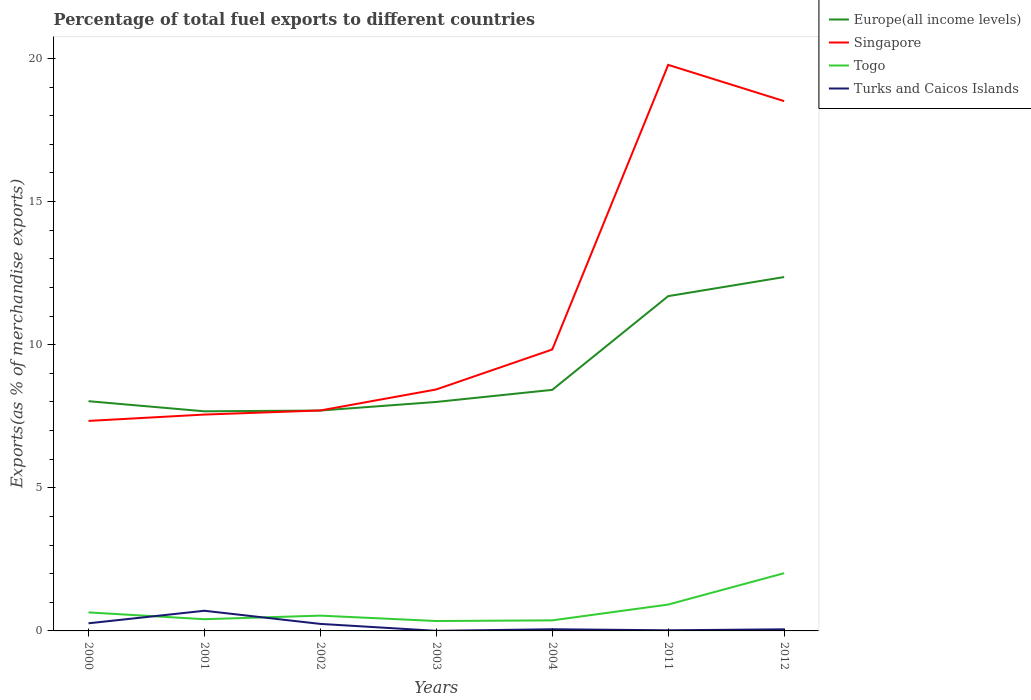Across all years, what is the maximum percentage of exports to different countries in Turks and Caicos Islands?
Offer a terse response. 0. What is the total percentage of exports to different countries in Singapore in the graph?
Offer a terse response. -2.13. What is the difference between the highest and the second highest percentage of exports to different countries in Togo?
Give a very brief answer. 1.67. What is the difference between the highest and the lowest percentage of exports to different countries in Europe(all income levels)?
Offer a terse response. 2. Is the percentage of exports to different countries in Turks and Caicos Islands strictly greater than the percentage of exports to different countries in Togo over the years?
Give a very brief answer. No. Are the values on the major ticks of Y-axis written in scientific E-notation?
Give a very brief answer. No. Does the graph contain any zero values?
Provide a short and direct response. No. Does the graph contain grids?
Ensure brevity in your answer.  No. How many legend labels are there?
Make the answer very short. 4. How are the legend labels stacked?
Offer a terse response. Vertical. What is the title of the graph?
Your response must be concise. Percentage of total fuel exports to different countries. Does "Tunisia" appear as one of the legend labels in the graph?
Your answer should be compact. No. What is the label or title of the Y-axis?
Offer a very short reply. Exports(as % of merchandise exports). What is the Exports(as % of merchandise exports) of Europe(all income levels) in 2000?
Offer a very short reply. 8.03. What is the Exports(as % of merchandise exports) in Singapore in 2000?
Give a very brief answer. 7.34. What is the Exports(as % of merchandise exports) in Togo in 2000?
Provide a short and direct response. 0.65. What is the Exports(as % of merchandise exports) in Turks and Caicos Islands in 2000?
Provide a short and direct response. 0.27. What is the Exports(as % of merchandise exports) in Europe(all income levels) in 2001?
Offer a terse response. 7.67. What is the Exports(as % of merchandise exports) in Singapore in 2001?
Make the answer very short. 7.56. What is the Exports(as % of merchandise exports) of Togo in 2001?
Your answer should be very brief. 0.41. What is the Exports(as % of merchandise exports) in Turks and Caicos Islands in 2001?
Your answer should be very brief. 0.7. What is the Exports(as % of merchandise exports) of Europe(all income levels) in 2002?
Make the answer very short. 7.7. What is the Exports(as % of merchandise exports) of Singapore in 2002?
Offer a very short reply. 7.7. What is the Exports(as % of merchandise exports) of Togo in 2002?
Your answer should be very brief. 0.53. What is the Exports(as % of merchandise exports) of Turks and Caicos Islands in 2002?
Make the answer very short. 0.24. What is the Exports(as % of merchandise exports) in Europe(all income levels) in 2003?
Your answer should be very brief. 8. What is the Exports(as % of merchandise exports) of Singapore in 2003?
Your response must be concise. 8.44. What is the Exports(as % of merchandise exports) of Togo in 2003?
Your answer should be compact. 0.35. What is the Exports(as % of merchandise exports) in Turks and Caicos Islands in 2003?
Give a very brief answer. 0. What is the Exports(as % of merchandise exports) of Europe(all income levels) in 2004?
Keep it short and to the point. 8.42. What is the Exports(as % of merchandise exports) in Singapore in 2004?
Make the answer very short. 9.83. What is the Exports(as % of merchandise exports) in Togo in 2004?
Your response must be concise. 0.37. What is the Exports(as % of merchandise exports) in Turks and Caicos Islands in 2004?
Your response must be concise. 0.06. What is the Exports(as % of merchandise exports) in Europe(all income levels) in 2011?
Offer a very short reply. 11.7. What is the Exports(as % of merchandise exports) in Singapore in 2011?
Ensure brevity in your answer.  19.78. What is the Exports(as % of merchandise exports) of Togo in 2011?
Keep it short and to the point. 0.92. What is the Exports(as % of merchandise exports) of Turks and Caicos Islands in 2011?
Offer a very short reply. 0.02. What is the Exports(as % of merchandise exports) of Europe(all income levels) in 2012?
Ensure brevity in your answer.  12.36. What is the Exports(as % of merchandise exports) in Singapore in 2012?
Ensure brevity in your answer.  18.51. What is the Exports(as % of merchandise exports) of Togo in 2012?
Give a very brief answer. 2.02. What is the Exports(as % of merchandise exports) of Turks and Caicos Islands in 2012?
Your answer should be very brief. 0.06. Across all years, what is the maximum Exports(as % of merchandise exports) of Europe(all income levels)?
Your answer should be very brief. 12.36. Across all years, what is the maximum Exports(as % of merchandise exports) of Singapore?
Ensure brevity in your answer.  19.78. Across all years, what is the maximum Exports(as % of merchandise exports) of Togo?
Offer a terse response. 2.02. Across all years, what is the maximum Exports(as % of merchandise exports) in Turks and Caicos Islands?
Provide a short and direct response. 0.7. Across all years, what is the minimum Exports(as % of merchandise exports) of Europe(all income levels)?
Offer a very short reply. 7.67. Across all years, what is the minimum Exports(as % of merchandise exports) in Singapore?
Offer a very short reply. 7.34. Across all years, what is the minimum Exports(as % of merchandise exports) of Togo?
Offer a very short reply. 0.35. Across all years, what is the minimum Exports(as % of merchandise exports) of Turks and Caicos Islands?
Make the answer very short. 0. What is the total Exports(as % of merchandise exports) in Europe(all income levels) in the graph?
Provide a short and direct response. 63.88. What is the total Exports(as % of merchandise exports) in Singapore in the graph?
Provide a short and direct response. 79.15. What is the total Exports(as % of merchandise exports) of Togo in the graph?
Provide a succinct answer. 5.24. What is the total Exports(as % of merchandise exports) in Turks and Caicos Islands in the graph?
Keep it short and to the point. 1.36. What is the difference between the Exports(as % of merchandise exports) of Europe(all income levels) in 2000 and that in 2001?
Your answer should be compact. 0.35. What is the difference between the Exports(as % of merchandise exports) of Singapore in 2000 and that in 2001?
Offer a very short reply. -0.22. What is the difference between the Exports(as % of merchandise exports) in Togo in 2000 and that in 2001?
Provide a short and direct response. 0.24. What is the difference between the Exports(as % of merchandise exports) in Turks and Caicos Islands in 2000 and that in 2001?
Offer a terse response. -0.44. What is the difference between the Exports(as % of merchandise exports) in Europe(all income levels) in 2000 and that in 2002?
Keep it short and to the point. 0.33. What is the difference between the Exports(as % of merchandise exports) in Singapore in 2000 and that in 2002?
Keep it short and to the point. -0.37. What is the difference between the Exports(as % of merchandise exports) in Togo in 2000 and that in 2002?
Your answer should be very brief. 0.11. What is the difference between the Exports(as % of merchandise exports) in Turks and Caicos Islands in 2000 and that in 2002?
Your answer should be very brief. 0.02. What is the difference between the Exports(as % of merchandise exports) of Europe(all income levels) in 2000 and that in 2003?
Make the answer very short. 0.03. What is the difference between the Exports(as % of merchandise exports) of Togo in 2000 and that in 2003?
Offer a terse response. 0.3. What is the difference between the Exports(as % of merchandise exports) in Turks and Caicos Islands in 2000 and that in 2003?
Offer a terse response. 0.26. What is the difference between the Exports(as % of merchandise exports) of Europe(all income levels) in 2000 and that in 2004?
Offer a very short reply. -0.4. What is the difference between the Exports(as % of merchandise exports) of Singapore in 2000 and that in 2004?
Make the answer very short. -2.5. What is the difference between the Exports(as % of merchandise exports) of Togo in 2000 and that in 2004?
Provide a succinct answer. 0.28. What is the difference between the Exports(as % of merchandise exports) of Turks and Caicos Islands in 2000 and that in 2004?
Provide a succinct answer. 0.21. What is the difference between the Exports(as % of merchandise exports) in Europe(all income levels) in 2000 and that in 2011?
Provide a succinct answer. -3.67. What is the difference between the Exports(as % of merchandise exports) in Singapore in 2000 and that in 2011?
Provide a succinct answer. -12.44. What is the difference between the Exports(as % of merchandise exports) in Togo in 2000 and that in 2011?
Make the answer very short. -0.27. What is the difference between the Exports(as % of merchandise exports) of Turks and Caicos Islands in 2000 and that in 2011?
Your answer should be compact. 0.24. What is the difference between the Exports(as % of merchandise exports) in Europe(all income levels) in 2000 and that in 2012?
Your answer should be compact. -4.34. What is the difference between the Exports(as % of merchandise exports) of Singapore in 2000 and that in 2012?
Make the answer very short. -11.17. What is the difference between the Exports(as % of merchandise exports) in Togo in 2000 and that in 2012?
Keep it short and to the point. -1.37. What is the difference between the Exports(as % of merchandise exports) in Turks and Caicos Islands in 2000 and that in 2012?
Offer a very short reply. 0.21. What is the difference between the Exports(as % of merchandise exports) in Europe(all income levels) in 2001 and that in 2002?
Your answer should be very brief. -0.03. What is the difference between the Exports(as % of merchandise exports) of Singapore in 2001 and that in 2002?
Give a very brief answer. -0.14. What is the difference between the Exports(as % of merchandise exports) in Togo in 2001 and that in 2002?
Offer a terse response. -0.13. What is the difference between the Exports(as % of merchandise exports) in Turks and Caicos Islands in 2001 and that in 2002?
Offer a very short reply. 0.46. What is the difference between the Exports(as % of merchandise exports) of Europe(all income levels) in 2001 and that in 2003?
Your answer should be very brief. -0.33. What is the difference between the Exports(as % of merchandise exports) in Singapore in 2001 and that in 2003?
Keep it short and to the point. -0.88. What is the difference between the Exports(as % of merchandise exports) of Togo in 2001 and that in 2003?
Ensure brevity in your answer.  0.06. What is the difference between the Exports(as % of merchandise exports) in Turks and Caicos Islands in 2001 and that in 2003?
Offer a terse response. 0.7. What is the difference between the Exports(as % of merchandise exports) in Europe(all income levels) in 2001 and that in 2004?
Offer a very short reply. -0.75. What is the difference between the Exports(as % of merchandise exports) of Singapore in 2001 and that in 2004?
Your answer should be compact. -2.27. What is the difference between the Exports(as % of merchandise exports) of Togo in 2001 and that in 2004?
Keep it short and to the point. 0.04. What is the difference between the Exports(as % of merchandise exports) in Turks and Caicos Islands in 2001 and that in 2004?
Your answer should be compact. 0.65. What is the difference between the Exports(as % of merchandise exports) in Europe(all income levels) in 2001 and that in 2011?
Ensure brevity in your answer.  -4.02. What is the difference between the Exports(as % of merchandise exports) of Singapore in 2001 and that in 2011?
Provide a short and direct response. -12.22. What is the difference between the Exports(as % of merchandise exports) of Togo in 2001 and that in 2011?
Your response must be concise. -0.51. What is the difference between the Exports(as % of merchandise exports) of Turks and Caicos Islands in 2001 and that in 2011?
Give a very brief answer. 0.68. What is the difference between the Exports(as % of merchandise exports) in Europe(all income levels) in 2001 and that in 2012?
Your answer should be very brief. -4.69. What is the difference between the Exports(as % of merchandise exports) of Singapore in 2001 and that in 2012?
Ensure brevity in your answer.  -10.95. What is the difference between the Exports(as % of merchandise exports) of Togo in 2001 and that in 2012?
Offer a terse response. -1.61. What is the difference between the Exports(as % of merchandise exports) in Turks and Caicos Islands in 2001 and that in 2012?
Offer a terse response. 0.65. What is the difference between the Exports(as % of merchandise exports) in Europe(all income levels) in 2002 and that in 2003?
Offer a very short reply. -0.3. What is the difference between the Exports(as % of merchandise exports) of Singapore in 2002 and that in 2003?
Your answer should be compact. -0.73. What is the difference between the Exports(as % of merchandise exports) of Togo in 2002 and that in 2003?
Provide a short and direct response. 0.19. What is the difference between the Exports(as % of merchandise exports) in Turks and Caicos Islands in 2002 and that in 2003?
Keep it short and to the point. 0.24. What is the difference between the Exports(as % of merchandise exports) of Europe(all income levels) in 2002 and that in 2004?
Make the answer very short. -0.72. What is the difference between the Exports(as % of merchandise exports) in Singapore in 2002 and that in 2004?
Keep it short and to the point. -2.13. What is the difference between the Exports(as % of merchandise exports) in Togo in 2002 and that in 2004?
Offer a very short reply. 0.17. What is the difference between the Exports(as % of merchandise exports) in Turks and Caicos Islands in 2002 and that in 2004?
Provide a short and direct response. 0.19. What is the difference between the Exports(as % of merchandise exports) in Europe(all income levels) in 2002 and that in 2011?
Provide a short and direct response. -4. What is the difference between the Exports(as % of merchandise exports) in Singapore in 2002 and that in 2011?
Offer a very short reply. -12.07. What is the difference between the Exports(as % of merchandise exports) in Togo in 2002 and that in 2011?
Provide a succinct answer. -0.39. What is the difference between the Exports(as % of merchandise exports) of Turks and Caicos Islands in 2002 and that in 2011?
Your answer should be very brief. 0.22. What is the difference between the Exports(as % of merchandise exports) of Europe(all income levels) in 2002 and that in 2012?
Give a very brief answer. -4.66. What is the difference between the Exports(as % of merchandise exports) of Singapore in 2002 and that in 2012?
Provide a short and direct response. -10.81. What is the difference between the Exports(as % of merchandise exports) in Togo in 2002 and that in 2012?
Your response must be concise. -1.48. What is the difference between the Exports(as % of merchandise exports) of Turks and Caicos Islands in 2002 and that in 2012?
Your response must be concise. 0.19. What is the difference between the Exports(as % of merchandise exports) in Europe(all income levels) in 2003 and that in 2004?
Give a very brief answer. -0.42. What is the difference between the Exports(as % of merchandise exports) of Singapore in 2003 and that in 2004?
Make the answer very short. -1.4. What is the difference between the Exports(as % of merchandise exports) of Togo in 2003 and that in 2004?
Provide a short and direct response. -0.02. What is the difference between the Exports(as % of merchandise exports) of Turks and Caicos Islands in 2003 and that in 2004?
Ensure brevity in your answer.  -0.06. What is the difference between the Exports(as % of merchandise exports) of Europe(all income levels) in 2003 and that in 2011?
Provide a succinct answer. -3.7. What is the difference between the Exports(as % of merchandise exports) in Singapore in 2003 and that in 2011?
Your answer should be compact. -11.34. What is the difference between the Exports(as % of merchandise exports) in Togo in 2003 and that in 2011?
Make the answer very short. -0.58. What is the difference between the Exports(as % of merchandise exports) of Turks and Caicos Islands in 2003 and that in 2011?
Offer a very short reply. -0.02. What is the difference between the Exports(as % of merchandise exports) in Europe(all income levels) in 2003 and that in 2012?
Provide a succinct answer. -4.36. What is the difference between the Exports(as % of merchandise exports) in Singapore in 2003 and that in 2012?
Ensure brevity in your answer.  -10.07. What is the difference between the Exports(as % of merchandise exports) in Togo in 2003 and that in 2012?
Provide a succinct answer. -1.67. What is the difference between the Exports(as % of merchandise exports) in Turks and Caicos Islands in 2003 and that in 2012?
Offer a terse response. -0.05. What is the difference between the Exports(as % of merchandise exports) of Europe(all income levels) in 2004 and that in 2011?
Offer a terse response. -3.27. What is the difference between the Exports(as % of merchandise exports) in Singapore in 2004 and that in 2011?
Keep it short and to the point. -9.94. What is the difference between the Exports(as % of merchandise exports) of Togo in 2004 and that in 2011?
Your response must be concise. -0.55. What is the difference between the Exports(as % of merchandise exports) of Turks and Caicos Islands in 2004 and that in 2011?
Give a very brief answer. 0.04. What is the difference between the Exports(as % of merchandise exports) in Europe(all income levels) in 2004 and that in 2012?
Your response must be concise. -3.94. What is the difference between the Exports(as % of merchandise exports) of Singapore in 2004 and that in 2012?
Ensure brevity in your answer.  -8.68. What is the difference between the Exports(as % of merchandise exports) in Togo in 2004 and that in 2012?
Keep it short and to the point. -1.65. What is the difference between the Exports(as % of merchandise exports) in Turks and Caicos Islands in 2004 and that in 2012?
Provide a short and direct response. 0. What is the difference between the Exports(as % of merchandise exports) of Europe(all income levels) in 2011 and that in 2012?
Your answer should be very brief. -0.67. What is the difference between the Exports(as % of merchandise exports) in Singapore in 2011 and that in 2012?
Make the answer very short. 1.27. What is the difference between the Exports(as % of merchandise exports) in Togo in 2011 and that in 2012?
Your answer should be compact. -1.1. What is the difference between the Exports(as % of merchandise exports) in Turks and Caicos Islands in 2011 and that in 2012?
Your answer should be compact. -0.04. What is the difference between the Exports(as % of merchandise exports) in Europe(all income levels) in 2000 and the Exports(as % of merchandise exports) in Singapore in 2001?
Provide a short and direct response. 0.47. What is the difference between the Exports(as % of merchandise exports) of Europe(all income levels) in 2000 and the Exports(as % of merchandise exports) of Togo in 2001?
Make the answer very short. 7.62. What is the difference between the Exports(as % of merchandise exports) of Europe(all income levels) in 2000 and the Exports(as % of merchandise exports) of Turks and Caicos Islands in 2001?
Offer a terse response. 7.32. What is the difference between the Exports(as % of merchandise exports) of Singapore in 2000 and the Exports(as % of merchandise exports) of Togo in 2001?
Your answer should be very brief. 6.93. What is the difference between the Exports(as % of merchandise exports) in Singapore in 2000 and the Exports(as % of merchandise exports) in Turks and Caicos Islands in 2001?
Ensure brevity in your answer.  6.63. What is the difference between the Exports(as % of merchandise exports) of Togo in 2000 and the Exports(as % of merchandise exports) of Turks and Caicos Islands in 2001?
Your answer should be very brief. -0.06. What is the difference between the Exports(as % of merchandise exports) in Europe(all income levels) in 2000 and the Exports(as % of merchandise exports) in Singapore in 2002?
Your response must be concise. 0.32. What is the difference between the Exports(as % of merchandise exports) in Europe(all income levels) in 2000 and the Exports(as % of merchandise exports) in Togo in 2002?
Make the answer very short. 7.49. What is the difference between the Exports(as % of merchandise exports) of Europe(all income levels) in 2000 and the Exports(as % of merchandise exports) of Turks and Caicos Islands in 2002?
Offer a very short reply. 7.78. What is the difference between the Exports(as % of merchandise exports) of Singapore in 2000 and the Exports(as % of merchandise exports) of Togo in 2002?
Offer a very short reply. 6.8. What is the difference between the Exports(as % of merchandise exports) in Singapore in 2000 and the Exports(as % of merchandise exports) in Turks and Caicos Islands in 2002?
Provide a short and direct response. 7.09. What is the difference between the Exports(as % of merchandise exports) of Togo in 2000 and the Exports(as % of merchandise exports) of Turks and Caicos Islands in 2002?
Keep it short and to the point. 0.4. What is the difference between the Exports(as % of merchandise exports) in Europe(all income levels) in 2000 and the Exports(as % of merchandise exports) in Singapore in 2003?
Make the answer very short. -0.41. What is the difference between the Exports(as % of merchandise exports) of Europe(all income levels) in 2000 and the Exports(as % of merchandise exports) of Togo in 2003?
Your answer should be very brief. 7.68. What is the difference between the Exports(as % of merchandise exports) of Europe(all income levels) in 2000 and the Exports(as % of merchandise exports) of Turks and Caicos Islands in 2003?
Keep it short and to the point. 8.02. What is the difference between the Exports(as % of merchandise exports) in Singapore in 2000 and the Exports(as % of merchandise exports) in Togo in 2003?
Offer a very short reply. 6.99. What is the difference between the Exports(as % of merchandise exports) of Singapore in 2000 and the Exports(as % of merchandise exports) of Turks and Caicos Islands in 2003?
Give a very brief answer. 7.33. What is the difference between the Exports(as % of merchandise exports) of Togo in 2000 and the Exports(as % of merchandise exports) of Turks and Caicos Islands in 2003?
Offer a very short reply. 0.64. What is the difference between the Exports(as % of merchandise exports) in Europe(all income levels) in 2000 and the Exports(as % of merchandise exports) in Singapore in 2004?
Offer a terse response. -1.81. What is the difference between the Exports(as % of merchandise exports) in Europe(all income levels) in 2000 and the Exports(as % of merchandise exports) in Togo in 2004?
Your answer should be compact. 7.66. What is the difference between the Exports(as % of merchandise exports) of Europe(all income levels) in 2000 and the Exports(as % of merchandise exports) of Turks and Caicos Islands in 2004?
Offer a very short reply. 7.97. What is the difference between the Exports(as % of merchandise exports) of Singapore in 2000 and the Exports(as % of merchandise exports) of Togo in 2004?
Offer a very short reply. 6.97. What is the difference between the Exports(as % of merchandise exports) of Singapore in 2000 and the Exports(as % of merchandise exports) of Turks and Caicos Islands in 2004?
Keep it short and to the point. 7.28. What is the difference between the Exports(as % of merchandise exports) in Togo in 2000 and the Exports(as % of merchandise exports) in Turks and Caicos Islands in 2004?
Offer a very short reply. 0.59. What is the difference between the Exports(as % of merchandise exports) in Europe(all income levels) in 2000 and the Exports(as % of merchandise exports) in Singapore in 2011?
Your answer should be compact. -11.75. What is the difference between the Exports(as % of merchandise exports) in Europe(all income levels) in 2000 and the Exports(as % of merchandise exports) in Togo in 2011?
Provide a short and direct response. 7.1. What is the difference between the Exports(as % of merchandise exports) of Europe(all income levels) in 2000 and the Exports(as % of merchandise exports) of Turks and Caicos Islands in 2011?
Give a very brief answer. 8. What is the difference between the Exports(as % of merchandise exports) of Singapore in 2000 and the Exports(as % of merchandise exports) of Togo in 2011?
Offer a very short reply. 6.42. What is the difference between the Exports(as % of merchandise exports) of Singapore in 2000 and the Exports(as % of merchandise exports) of Turks and Caicos Islands in 2011?
Keep it short and to the point. 7.32. What is the difference between the Exports(as % of merchandise exports) in Togo in 2000 and the Exports(as % of merchandise exports) in Turks and Caicos Islands in 2011?
Provide a succinct answer. 0.62. What is the difference between the Exports(as % of merchandise exports) of Europe(all income levels) in 2000 and the Exports(as % of merchandise exports) of Singapore in 2012?
Give a very brief answer. -10.48. What is the difference between the Exports(as % of merchandise exports) in Europe(all income levels) in 2000 and the Exports(as % of merchandise exports) in Togo in 2012?
Keep it short and to the point. 6.01. What is the difference between the Exports(as % of merchandise exports) in Europe(all income levels) in 2000 and the Exports(as % of merchandise exports) in Turks and Caicos Islands in 2012?
Make the answer very short. 7.97. What is the difference between the Exports(as % of merchandise exports) of Singapore in 2000 and the Exports(as % of merchandise exports) of Togo in 2012?
Keep it short and to the point. 5.32. What is the difference between the Exports(as % of merchandise exports) of Singapore in 2000 and the Exports(as % of merchandise exports) of Turks and Caicos Islands in 2012?
Your answer should be very brief. 7.28. What is the difference between the Exports(as % of merchandise exports) in Togo in 2000 and the Exports(as % of merchandise exports) in Turks and Caicos Islands in 2012?
Your answer should be very brief. 0.59. What is the difference between the Exports(as % of merchandise exports) of Europe(all income levels) in 2001 and the Exports(as % of merchandise exports) of Singapore in 2002?
Ensure brevity in your answer.  -0.03. What is the difference between the Exports(as % of merchandise exports) of Europe(all income levels) in 2001 and the Exports(as % of merchandise exports) of Togo in 2002?
Provide a succinct answer. 7.14. What is the difference between the Exports(as % of merchandise exports) of Europe(all income levels) in 2001 and the Exports(as % of merchandise exports) of Turks and Caicos Islands in 2002?
Provide a succinct answer. 7.43. What is the difference between the Exports(as % of merchandise exports) of Singapore in 2001 and the Exports(as % of merchandise exports) of Togo in 2002?
Your answer should be compact. 7.03. What is the difference between the Exports(as % of merchandise exports) in Singapore in 2001 and the Exports(as % of merchandise exports) in Turks and Caicos Islands in 2002?
Offer a terse response. 7.31. What is the difference between the Exports(as % of merchandise exports) in Togo in 2001 and the Exports(as % of merchandise exports) in Turks and Caicos Islands in 2002?
Offer a terse response. 0.16. What is the difference between the Exports(as % of merchandise exports) in Europe(all income levels) in 2001 and the Exports(as % of merchandise exports) in Singapore in 2003?
Your answer should be compact. -0.76. What is the difference between the Exports(as % of merchandise exports) of Europe(all income levels) in 2001 and the Exports(as % of merchandise exports) of Togo in 2003?
Your response must be concise. 7.33. What is the difference between the Exports(as % of merchandise exports) in Europe(all income levels) in 2001 and the Exports(as % of merchandise exports) in Turks and Caicos Islands in 2003?
Give a very brief answer. 7.67. What is the difference between the Exports(as % of merchandise exports) in Singapore in 2001 and the Exports(as % of merchandise exports) in Togo in 2003?
Your response must be concise. 7.21. What is the difference between the Exports(as % of merchandise exports) of Singapore in 2001 and the Exports(as % of merchandise exports) of Turks and Caicos Islands in 2003?
Make the answer very short. 7.56. What is the difference between the Exports(as % of merchandise exports) of Togo in 2001 and the Exports(as % of merchandise exports) of Turks and Caicos Islands in 2003?
Make the answer very short. 0.41. What is the difference between the Exports(as % of merchandise exports) in Europe(all income levels) in 2001 and the Exports(as % of merchandise exports) in Singapore in 2004?
Your answer should be compact. -2.16. What is the difference between the Exports(as % of merchandise exports) of Europe(all income levels) in 2001 and the Exports(as % of merchandise exports) of Togo in 2004?
Ensure brevity in your answer.  7.3. What is the difference between the Exports(as % of merchandise exports) of Europe(all income levels) in 2001 and the Exports(as % of merchandise exports) of Turks and Caicos Islands in 2004?
Your answer should be compact. 7.61. What is the difference between the Exports(as % of merchandise exports) of Singapore in 2001 and the Exports(as % of merchandise exports) of Togo in 2004?
Offer a very short reply. 7.19. What is the difference between the Exports(as % of merchandise exports) in Singapore in 2001 and the Exports(as % of merchandise exports) in Turks and Caicos Islands in 2004?
Ensure brevity in your answer.  7.5. What is the difference between the Exports(as % of merchandise exports) of Togo in 2001 and the Exports(as % of merchandise exports) of Turks and Caicos Islands in 2004?
Ensure brevity in your answer.  0.35. What is the difference between the Exports(as % of merchandise exports) in Europe(all income levels) in 2001 and the Exports(as % of merchandise exports) in Singapore in 2011?
Provide a succinct answer. -12.1. What is the difference between the Exports(as % of merchandise exports) of Europe(all income levels) in 2001 and the Exports(as % of merchandise exports) of Togo in 2011?
Keep it short and to the point. 6.75. What is the difference between the Exports(as % of merchandise exports) of Europe(all income levels) in 2001 and the Exports(as % of merchandise exports) of Turks and Caicos Islands in 2011?
Keep it short and to the point. 7.65. What is the difference between the Exports(as % of merchandise exports) in Singapore in 2001 and the Exports(as % of merchandise exports) in Togo in 2011?
Give a very brief answer. 6.64. What is the difference between the Exports(as % of merchandise exports) in Singapore in 2001 and the Exports(as % of merchandise exports) in Turks and Caicos Islands in 2011?
Offer a very short reply. 7.54. What is the difference between the Exports(as % of merchandise exports) of Togo in 2001 and the Exports(as % of merchandise exports) of Turks and Caicos Islands in 2011?
Make the answer very short. 0.39. What is the difference between the Exports(as % of merchandise exports) in Europe(all income levels) in 2001 and the Exports(as % of merchandise exports) in Singapore in 2012?
Give a very brief answer. -10.84. What is the difference between the Exports(as % of merchandise exports) in Europe(all income levels) in 2001 and the Exports(as % of merchandise exports) in Togo in 2012?
Your response must be concise. 5.66. What is the difference between the Exports(as % of merchandise exports) in Europe(all income levels) in 2001 and the Exports(as % of merchandise exports) in Turks and Caicos Islands in 2012?
Provide a short and direct response. 7.62. What is the difference between the Exports(as % of merchandise exports) of Singapore in 2001 and the Exports(as % of merchandise exports) of Togo in 2012?
Give a very brief answer. 5.54. What is the difference between the Exports(as % of merchandise exports) in Singapore in 2001 and the Exports(as % of merchandise exports) in Turks and Caicos Islands in 2012?
Make the answer very short. 7.5. What is the difference between the Exports(as % of merchandise exports) in Togo in 2001 and the Exports(as % of merchandise exports) in Turks and Caicos Islands in 2012?
Your answer should be compact. 0.35. What is the difference between the Exports(as % of merchandise exports) of Europe(all income levels) in 2002 and the Exports(as % of merchandise exports) of Singapore in 2003?
Your answer should be very brief. -0.74. What is the difference between the Exports(as % of merchandise exports) of Europe(all income levels) in 2002 and the Exports(as % of merchandise exports) of Togo in 2003?
Offer a very short reply. 7.35. What is the difference between the Exports(as % of merchandise exports) of Europe(all income levels) in 2002 and the Exports(as % of merchandise exports) of Turks and Caicos Islands in 2003?
Offer a terse response. 7.7. What is the difference between the Exports(as % of merchandise exports) of Singapore in 2002 and the Exports(as % of merchandise exports) of Togo in 2003?
Provide a short and direct response. 7.36. What is the difference between the Exports(as % of merchandise exports) in Singapore in 2002 and the Exports(as % of merchandise exports) in Turks and Caicos Islands in 2003?
Ensure brevity in your answer.  7.7. What is the difference between the Exports(as % of merchandise exports) of Togo in 2002 and the Exports(as % of merchandise exports) of Turks and Caicos Islands in 2003?
Offer a very short reply. 0.53. What is the difference between the Exports(as % of merchandise exports) in Europe(all income levels) in 2002 and the Exports(as % of merchandise exports) in Singapore in 2004?
Provide a short and direct response. -2.13. What is the difference between the Exports(as % of merchandise exports) in Europe(all income levels) in 2002 and the Exports(as % of merchandise exports) in Togo in 2004?
Give a very brief answer. 7.33. What is the difference between the Exports(as % of merchandise exports) in Europe(all income levels) in 2002 and the Exports(as % of merchandise exports) in Turks and Caicos Islands in 2004?
Your answer should be very brief. 7.64. What is the difference between the Exports(as % of merchandise exports) in Singapore in 2002 and the Exports(as % of merchandise exports) in Togo in 2004?
Give a very brief answer. 7.33. What is the difference between the Exports(as % of merchandise exports) of Singapore in 2002 and the Exports(as % of merchandise exports) of Turks and Caicos Islands in 2004?
Provide a succinct answer. 7.64. What is the difference between the Exports(as % of merchandise exports) in Togo in 2002 and the Exports(as % of merchandise exports) in Turks and Caicos Islands in 2004?
Provide a succinct answer. 0.48. What is the difference between the Exports(as % of merchandise exports) in Europe(all income levels) in 2002 and the Exports(as % of merchandise exports) in Singapore in 2011?
Offer a very short reply. -12.08. What is the difference between the Exports(as % of merchandise exports) of Europe(all income levels) in 2002 and the Exports(as % of merchandise exports) of Togo in 2011?
Give a very brief answer. 6.78. What is the difference between the Exports(as % of merchandise exports) in Europe(all income levels) in 2002 and the Exports(as % of merchandise exports) in Turks and Caicos Islands in 2011?
Offer a terse response. 7.68. What is the difference between the Exports(as % of merchandise exports) in Singapore in 2002 and the Exports(as % of merchandise exports) in Togo in 2011?
Make the answer very short. 6.78. What is the difference between the Exports(as % of merchandise exports) of Singapore in 2002 and the Exports(as % of merchandise exports) of Turks and Caicos Islands in 2011?
Your answer should be very brief. 7.68. What is the difference between the Exports(as % of merchandise exports) in Togo in 2002 and the Exports(as % of merchandise exports) in Turks and Caicos Islands in 2011?
Provide a succinct answer. 0.51. What is the difference between the Exports(as % of merchandise exports) of Europe(all income levels) in 2002 and the Exports(as % of merchandise exports) of Singapore in 2012?
Provide a succinct answer. -10.81. What is the difference between the Exports(as % of merchandise exports) in Europe(all income levels) in 2002 and the Exports(as % of merchandise exports) in Togo in 2012?
Keep it short and to the point. 5.68. What is the difference between the Exports(as % of merchandise exports) in Europe(all income levels) in 2002 and the Exports(as % of merchandise exports) in Turks and Caicos Islands in 2012?
Ensure brevity in your answer.  7.64. What is the difference between the Exports(as % of merchandise exports) in Singapore in 2002 and the Exports(as % of merchandise exports) in Togo in 2012?
Give a very brief answer. 5.68. What is the difference between the Exports(as % of merchandise exports) in Singapore in 2002 and the Exports(as % of merchandise exports) in Turks and Caicos Islands in 2012?
Keep it short and to the point. 7.65. What is the difference between the Exports(as % of merchandise exports) in Togo in 2002 and the Exports(as % of merchandise exports) in Turks and Caicos Islands in 2012?
Keep it short and to the point. 0.48. What is the difference between the Exports(as % of merchandise exports) of Europe(all income levels) in 2003 and the Exports(as % of merchandise exports) of Singapore in 2004?
Make the answer very short. -1.83. What is the difference between the Exports(as % of merchandise exports) of Europe(all income levels) in 2003 and the Exports(as % of merchandise exports) of Togo in 2004?
Make the answer very short. 7.63. What is the difference between the Exports(as % of merchandise exports) of Europe(all income levels) in 2003 and the Exports(as % of merchandise exports) of Turks and Caicos Islands in 2004?
Offer a very short reply. 7.94. What is the difference between the Exports(as % of merchandise exports) in Singapore in 2003 and the Exports(as % of merchandise exports) in Togo in 2004?
Your answer should be compact. 8.07. What is the difference between the Exports(as % of merchandise exports) of Singapore in 2003 and the Exports(as % of merchandise exports) of Turks and Caicos Islands in 2004?
Give a very brief answer. 8.38. What is the difference between the Exports(as % of merchandise exports) in Togo in 2003 and the Exports(as % of merchandise exports) in Turks and Caicos Islands in 2004?
Offer a very short reply. 0.29. What is the difference between the Exports(as % of merchandise exports) of Europe(all income levels) in 2003 and the Exports(as % of merchandise exports) of Singapore in 2011?
Keep it short and to the point. -11.78. What is the difference between the Exports(as % of merchandise exports) of Europe(all income levels) in 2003 and the Exports(as % of merchandise exports) of Togo in 2011?
Keep it short and to the point. 7.08. What is the difference between the Exports(as % of merchandise exports) in Europe(all income levels) in 2003 and the Exports(as % of merchandise exports) in Turks and Caicos Islands in 2011?
Give a very brief answer. 7.98. What is the difference between the Exports(as % of merchandise exports) of Singapore in 2003 and the Exports(as % of merchandise exports) of Togo in 2011?
Make the answer very short. 7.52. What is the difference between the Exports(as % of merchandise exports) in Singapore in 2003 and the Exports(as % of merchandise exports) in Turks and Caicos Islands in 2011?
Provide a succinct answer. 8.42. What is the difference between the Exports(as % of merchandise exports) in Togo in 2003 and the Exports(as % of merchandise exports) in Turks and Caicos Islands in 2011?
Give a very brief answer. 0.32. What is the difference between the Exports(as % of merchandise exports) of Europe(all income levels) in 2003 and the Exports(as % of merchandise exports) of Singapore in 2012?
Your answer should be compact. -10.51. What is the difference between the Exports(as % of merchandise exports) of Europe(all income levels) in 2003 and the Exports(as % of merchandise exports) of Togo in 2012?
Your answer should be compact. 5.98. What is the difference between the Exports(as % of merchandise exports) of Europe(all income levels) in 2003 and the Exports(as % of merchandise exports) of Turks and Caicos Islands in 2012?
Your response must be concise. 7.94. What is the difference between the Exports(as % of merchandise exports) of Singapore in 2003 and the Exports(as % of merchandise exports) of Togo in 2012?
Offer a very short reply. 6.42. What is the difference between the Exports(as % of merchandise exports) in Singapore in 2003 and the Exports(as % of merchandise exports) in Turks and Caicos Islands in 2012?
Your response must be concise. 8.38. What is the difference between the Exports(as % of merchandise exports) in Togo in 2003 and the Exports(as % of merchandise exports) in Turks and Caicos Islands in 2012?
Provide a succinct answer. 0.29. What is the difference between the Exports(as % of merchandise exports) in Europe(all income levels) in 2004 and the Exports(as % of merchandise exports) in Singapore in 2011?
Offer a very short reply. -11.35. What is the difference between the Exports(as % of merchandise exports) of Europe(all income levels) in 2004 and the Exports(as % of merchandise exports) of Togo in 2011?
Your response must be concise. 7.5. What is the difference between the Exports(as % of merchandise exports) of Europe(all income levels) in 2004 and the Exports(as % of merchandise exports) of Turks and Caicos Islands in 2011?
Offer a very short reply. 8.4. What is the difference between the Exports(as % of merchandise exports) in Singapore in 2004 and the Exports(as % of merchandise exports) in Togo in 2011?
Provide a succinct answer. 8.91. What is the difference between the Exports(as % of merchandise exports) in Singapore in 2004 and the Exports(as % of merchandise exports) in Turks and Caicos Islands in 2011?
Keep it short and to the point. 9.81. What is the difference between the Exports(as % of merchandise exports) in Togo in 2004 and the Exports(as % of merchandise exports) in Turks and Caicos Islands in 2011?
Your answer should be compact. 0.35. What is the difference between the Exports(as % of merchandise exports) of Europe(all income levels) in 2004 and the Exports(as % of merchandise exports) of Singapore in 2012?
Provide a succinct answer. -10.09. What is the difference between the Exports(as % of merchandise exports) of Europe(all income levels) in 2004 and the Exports(as % of merchandise exports) of Togo in 2012?
Keep it short and to the point. 6.4. What is the difference between the Exports(as % of merchandise exports) in Europe(all income levels) in 2004 and the Exports(as % of merchandise exports) in Turks and Caicos Islands in 2012?
Offer a very short reply. 8.37. What is the difference between the Exports(as % of merchandise exports) of Singapore in 2004 and the Exports(as % of merchandise exports) of Togo in 2012?
Offer a terse response. 7.81. What is the difference between the Exports(as % of merchandise exports) of Singapore in 2004 and the Exports(as % of merchandise exports) of Turks and Caicos Islands in 2012?
Keep it short and to the point. 9.78. What is the difference between the Exports(as % of merchandise exports) of Togo in 2004 and the Exports(as % of merchandise exports) of Turks and Caicos Islands in 2012?
Ensure brevity in your answer.  0.31. What is the difference between the Exports(as % of merchandise exports) of Europe(all income levels) in 2011 and the Exports(as % of merchandise exports) of Singapore in 2012?
Offer a terse response. -6.81. What is the difference between the Exports(as % of merchandise exports) of Europe(all income levels) in 2011 and the Exports(as % of merchandise exports) of Togo in 2012?
Your response must be concise. 9.68. What is the difference between the Exports(as % of merchandise exports) in Europe(all income levels) in 2011 and the Exports(as % of merchandise exports) in Turks and Caicos Islands in 2012?
Offer a very short reply. 11.64. What is the difference between the Exports(as % of merchandise exports) in Singapore in 2011 and the Exports(as % of merchandise exports) in Togo in 2012?
Make the answer very short. 17.76. What is the difference between the Exports(as % of merchandise exports) of Singapore in 2011 and the Exports(as % of merchandise exports) of Turks and Caicos Islands in 2012?
Your response must be concise. 19.72. What is the difference between the Exports(as % of merchandise exports) in Togo in 2011 and the Exports(as % of merchandise exports) in Turks and Caicos Islands in 2012?
Keep it short and to the point. 0.86. What is the average Exports(as % of merchandise exports) of Europe(all income levels) per year?
Your response must be concise. 9.13. What is the average Exports(as % of merchandise exports) in Singapore per year?
Your response must be concise. 11.31. What is the average Exports(as % of merchandise exports) of Togo per year?
Make the answer very short. 0.75. What is the average Exports(as % of merchandise exports) in Turks and Caicos Islands per year?
Offer a very short reply. 0.19. In the year 2000, what is the difference between the Exports(as % of merchandise exports) of Europe(all income levels) and Exports(as % of merchandise exports) of Singapore?
Provide a succinct answer. 0.69. In the year 2000, what is the difference between the Exports(as % of merchandise exports) in Europe(all income levels) and Exports(as % of merchandise exports) in Togo?
Keep it short and to the point. 7.38. In the year 2000, what is the difference between the Exports(as % of merchandise exports) in Europe(all income levels) and Exports(as % of merchandise exports) in Turks and Caicos Islands?
Offer a very short reply. 7.76. In the year 2000, what is the difference between the Exports(as % of merchandise exports) of Singapore and Exports(as % of merchandise exports) of Togo?
Ensure brevity in your answer.  6.69. In the year 2000, what is the difference between the Exports(as % of merchandise exports) of Singapore and Exports(as % of merchandise exports) of Turks and Caicos Islands?
Provide a succinct answer. 7.07. In the year 2000, what is the difference between the Exports(as % of merchandise exports) in Togo and Exports(as % of merchandise exports) in Turks and Caicos Islands?
Provide a short and direct response. 0.38. In the year 2001, what is the difference between the Exports(as % of merchandise exports) in Europe(all income levels) and Exports(as % of merchandise exports) in Singapore?
Provide a short and direct response. 0.11. In the year 2001, what is the difference between the Exports(as % of merchandise exports) of Europe(all income levels) and Exports(as % of merchandise exports) of Togo?
Make the answer very short. 7.26. In the year 2001, what is the difference between the Exports(as % of merchandise exports) of Europe(all income levels) and Exports(as % of merchandise exports) of Turks and Caicos Islands?
Your answer should be compact. 6.97. In the year 2001, what is the difference between the Exports(as % of merchandise exports) in Singapore and Exports(as % of merchandise exports) in Togo?
Make the answer very short. 7.15. In the year 2001, what is the difference between the Exports(as % of merchandise exports) in Singapore and Exports(as % of merchandise exports) in Turks and Caicos Islands?
Your answer should be compact. 6.85. In the year 2001, what is the difference between the Exports(as % of merchandise exports) in Togo and Exports(as % of merchandise exports) in Turks and Caicos Islands?
Ensure brevity in your answer.  -0.3. In the year 2002, what is the difference between the Exports(as % of merchandise exports) of Europe(all income levels) and Exports(as % of merchandise exports) of Singapore?
Give a very brief answer. -0. In the year 2002, what is the difference between the Exports(as % of merchandise exports) in Europe(all income levels) and Exports(as % of merchandise exports) in Togo?
Keep it short and to the point. 7.17. In the year 2002, what is the difference between the Exports(as % of merchandise exports) of Europe(all income levels) and Exports(as % of merchandise exports) of Turks and Caicos Islands?
Give a very brief answer. 7.46. In the year 2002, what is the difference between the Exports(as % of merchandise exports) in Singapore and Exports(as % of merchandise exports) in Togo?
Offer a very short reply. 7.17. In the year 2002, what is the difference between the Exports(as % of merchandise exports) of Singapore and Exports(as % of merchandise exports) of Turks and Caicos Islands?
Offer a very short reply. 7.46. In the year 2002, what is the difference between the Exports(as % of merchandise exports) of Togo and Exports(as % of merchandise exports) of Turks and Caicos Islands?
Your response must be concise. 0.29. In the year 2003, what is the difference between the Exports(as % of merchandise exports) in Europe(all income levels) and Exports(as % of merchandise exports) in Singapore?
Your answer should be compact. -0.44. In the year 2003, what is the difference between the Exports(as % of merchandise exports) of Europe(all income levels) and Exports(as % of merchandise exports) of Togo?
Keep it short and to the point. 7.65. In the year 2003, what is the difference between the Exports(as % of merchandise exports) of Europe(all income levels) and Exports(as % of merchandise exports) of Turks and Caicos Islands?
Offer a very short reply. 8. In the year 2003, what is the difference between the Exports(as % of merchandise exports) of Singapore and Exports(as % of merchandise exports) of Togo?
Make the answer very short. 8.09. In the year 2003, what is the difference between the Exports(as % of merchandise exports) in Singapore and Exports(as % of merchandise exports) in Turks and Caicos Islands?
Provide a succinct answer. 8.43. In the year 2003, what is the difference between the Exports(as % of merchandise exports) in Togo and Exports(as % of merchandise exports) in Turks and Caicos Islands?
Your answer should be compact. 0.34. In the year 2004, what is the difference between the Exports(as % of merchandise exports) in Europe(all income levels) and Exports(as % of merchandise exports) in Singapore?
Keep it short and to the point. -1.41. In the year 2004, what is the difference between the Exports(as % of merchandise exports) of Europe(all income levels) and Exports(as % of merchandise exports) of Togo?
Offer a terse response. 8.05. In the year 2004, what is the difference between the Exports(as % of merchandise exports) of Europe(all income levels) and Exports(as % of merchandise exports) of Turks and Caicos Islands?
Your response must be concise. 8.36. In the year 2004, what is the difference between the Exports(as % of merchandise exports) of Singapore and Exports(as % of merchandise exports) of Togo?
Provide a succinct answer. 9.46. In the year 2004, what is the difference between the Exports(as % of merchandise exports) of Singapore and Exports(as % of merchandise exports) of Turks and Caicos Islands?
Ensure brevity in your answer.  9.77. In the year 2004, what is the difference between the Exports(as % of merchandise exports) of Togo and Exports(as % of merchandise exports) of Turks and Caicos Islands?
Keep it short and to the point. 0.31. In the year 2011, what is the difference between the Exports(as % of merchandise exports) of Europe(all income levels) and Exports(as % of merchandise exports) of Singapore?
Give a very brief answer. -8.08. In the year 2011, what is the difference between the Exports(as % of merchandise exports) in Europe(all income levels) and Exports(as % of merchandise exports) in Togo?
Make the answer very short. 10.78. In the year 2011, what is the difference between the Exports(as % of merchandise exports) in Europe(all income levels) and Exports(as % of merchandise exports) in Turks and Caicos Islands?
Provide a succinct answer. 11.68. In the year 2011, what is the difference between the Exports(as % of merchandise exports) of Singapore and Exports(as % of merchandise exports) of Togo?
Keep it short and to the point. 18.86. In the year 2011, what is the difference between the Exports(as % of merchandise exports) of Singapore and Exports(as % of merchandise exports) of Turks and Caicos Islands?
Make the answer very short. 19.75. In the year 2011, what is the difference between the Exports(as % of merchandise exports) of Togo and Exports(as % of merchandise exports) of Turks and Caicos Islands?
Your answer should be very brief. 0.9. In the year 2012, what is the difference between the Exports(as % of merchandise exports) in Europe(all income levels) and Exports(as % of merchandise exports) in Singapore?
Offer a very short reply. -6.15. In the year 2012, what is the difference between the Exports(as % of merchandise exports) in Europe(all income levels) and Exports(as % of merchandise exports) in Togo?
Offer a terse response. 10.35. In the year 2012, what is the difference between the Exports(as % of merchandise exports) in Europe(all income levels) and Exports(as % of merchandise exports) in Turks and Caicos Islands?
Provide a succinct answer. 12.31. In the year 2012, what is the difference between the Exports(as % of merchandise exports) in Singapore and Exports(as % of merchandise exports) in Togo?
Keep it short and to the point. 16.49. In the year 2012, what is the difference between the Exports(as % of merchandise exports) of Singapore and Exports(as % of merchandise exports) of Turks and Caicos Islands?
Keep it short and to the point. 18.45. In the year 2012, what is the difference between the Exports(as % of merchandise exports) of Togo and Exports(as % of merchandise exports) of Turks and Caicos Islands?
Provide a succinct answer. 1.96. What is the ratio of the Exports(as % of merchandise exports) in Europe(all income levels) in 2000 to that in 2001?
Keep it short and to the point. 1.05. What is the ratio of the Exports(as % of merchandise exports) of Singapore in 2000 to that in 2001?
Keep it short and to the point. 0.97. What is the ratio of the Exports(as % of merchandise exports) of Togo in 2000 to that in 2001?
Give a very brief answer. 1.58. What is the ratio of the Exports(as % of merchandise exports) in Turks and Caicos Islands in 2000 to that in 2001?
Ensure brevity in your answer.  0.38. What is the ratio of the Exports(as % of merchandise exports) of Europe(all income levels) in 2000 to that in 2002?
Offer a very short reply. 1.04. What is the ratio of the Exports(as % of merchandise exports) in Singapore in 2000 to that in 2002?
Your answer should be very brief. 0.95. What is the ratio of the Exports(as % of merchandise exports) of Togo in 2000 to that in 2002?
Your answer should be compact. 1.21. What is the ratio of the Exports(as % of merchandise exports) in Turks and Caicos Islands in 2000 to that in 2002?
Your response must be concise. 1.09. What is the ratio of the Exports(as % of merchandise exports) of Europe(all income levels) in 2000 to that in 2003?
Provide a succinct answer. 1. What is the ratio of the Exports(as % of merchandise exports) in Singapore in 2000 to that in 2003?
Your response must be concise. 0.87. What is the ratio of the Exports(as % of merchandise exports) in Togo in 2000 to that in 2003?
Give a very brief answer. 1.87. What is the ratio of the Exports(as % of merchandise exports) of Turks and Caicos Islands in 2000 to that in 2003?
Give a very brief answer. 89.53. What is the ratio of the Exports(as % of merchandise exports) in Europe(all income levels) in 2000 to that in 2004?
Your answer should be compact. 0.95. What is the ratio of the Exports(as % of merchandise exports) of Singapore in 2000 to that in 2004?
Keep it short and to the point. 0.75. What is the ratio of the Exports(as % of merchandise exports) in Togo in 2000 to that in 2004?
Ensure brevity in your answer.  1.75. What is the ratio of the Exports(as % of merchandise exports) in Turks and Caicos Islands in 2000 to that in 2004?
Make the answer very short. 4.51. What is the ratio of the Exports(as % of merchandise exports) in Europe(all income levels) in 2000 to that in 2011?
Provide a succinct answer. 0.69. What is the ratio of the Exports(as % of merchandise exports) in Singapore in 2000 to that in 2011?
Ensure brevity in your answer.  0.37. What is the ratio of the Exports(as % of merchandise exports) of Togo in 2000 to that in 2011?
Your response must be concise. 0.7. What is the ratio of the Exports(as % of merchandise exports) in Turks and Caicos Islands in 2000 to that in 2011?
Give a very brief answer. 12.22. What is the ratio of the Exports(as % of merchandise exports) in Europe(all income levels) in 2000 to that in 2012?
Offer a terse response. 0.65. What is the ratio of the Exports(as % of merchandise exports) in Singapore in 2000 to that in 2012?
Keep it short and to the point. 0.4. What is the ratio of the Exports(as % of merchandise exports) of Togo in 2000 to that in 2012?
Give a very brief answer. 0.32. What is the ratio of the Exports(as % of merchandise exports) of Turks and Caicos Islands in 2000 to that in 2012?
Your response must be concise. 4.68. What is the ratio of the Exports(as % of merchandise exports) in Europe(all income levels) in 2001 to that in 2002?
Make the answer very short. 1. What is the ratio of the Exports(as % of merchandise exports) of Singapore in 2001 to that in 2002?
Your answer should be compact. 0.98. What is the ratio of the Exports(as % of merchandise exports) in Togo in 2001 to that in 2002?
Your answer should be very brief. 0.77. What is the ratio of the Exports(as % of merchandise exports) in Turks and Caicos Islands in 2001 to that in 2002?
Your answer should be very brief. 2.88. What is the ratio of the Exports(as % of merchandise exports) of Europe(all income levels) in 2001 to that in 2003?
Your answer should be very brief. 0.96. What is the ratio of the Exports(as % of merchandise exports) in Singapore in 2001 to that in 2003?
Give a very brief answer. 0.9. What is the ratio of the Exports(as % of merchandise exports) in Togo in 2001 to that in 2003?
Give a very brief answer. 1.18. What is the ratio of the Exports(as % of merchandise exports) in Turks and Caicos Islands in 2001 to that in 2003?
Your answer should be compact. 236.85. What is the ratio of the Exports(as % of merchandise exports) in Europe(all income levels) in 2001 to that in 2004?
Your answer should be compact. 0.91. What is the ratio of the Exports(as % of merchandise exports) of Singapore in 2001 to that in 2004?
Keep it short and to the point. 0.77. What is the ratio of the Exports(as % of merchandise exports) of Togo in 2001 to that in 2004?
Give a very brief answer. 1.11. What is the ratio of the Exports(as % of merchandise exports) of Turks and Caicos Islands in 2001 to that in 2004?
Give a very brief answer. 11.94. What is the ratio of the Exports(as % of merchandise exports) in Europe(all income levels) in 2001 to that in 2011?
Your response must be concise. 0.66. What is the ratio of the Exports(as % of merchandise exports) of Singapore in 2001 to that in 2011?
Your answer should be very brief. 0.38. What is the ratio of the Exports(as % of merchandise exports) in Togo in 2001 to that in 2011?
Offer a terse response. 0.44. What is the ratio of the Exports(as % of merchandise exports) of Turks and Caicos Islands in 2001 to that in 2011?
Ensure brevity in your answer.  32.32. What is the ratio of the Exports(as % of merchandise exports) of Europe(all income levels) in 2001 to that in 2012?
Your answer should be compact. 0.62. What is the ratio of the Exports(as % of merchandise exports) in Singapore in 2001 to that in 2012?
Provide a succinct answer. 0.41. What is the ratio of the Exports(as % of merchandise exports) in Togo in 2001 to that in 2012?
Ensure brevity in your answer.  0.2. What is the ratio of the Exports(as % of merchandise exports) in Turks and Caicos Islands in 2001 to that in 2012?
Provide a succinct answer. 12.37. What is the ratio of the Exports(as % of merchandise exports) in Europe(all income levels) in 2002 to that in 2003?
Provide a short and direct response. 0.96. What is the ratio of the Exports(as % of merchandise exports) of Singapore in 2002 to that in 2003?
Make the answer very short. 0.91. What is the ratio of the Exports(as % of merchandise exports) in Togo in 2002 to that in 2003?
Offer a terse response. 1.54. What is the ratio of the Exports(as % of merchandise exports) in Turks and Caicos Islands in 2002 to that in 2003?
Your response must be concise. 82.32. What is the ratio of the Exports(as % of merchandise exports) of Europe(all income levels) in 2002 to that in 2004?
Offer a terse response. 0.91. What is the ratio of the Exports(as % of merchandise exports) in Singapore in 2002 to that in 2004?
Your answer should be compact. 0.78. What is the ratio of the Exports(as % of merchandise exports) in Togo in 2002 to that in 2004?
Make the answer very short. 1.45. What is the ratio of the Exports(as % of merchandise exports) in Turks and Caicos Islands in 2002 to that in 2004?
Offer a terse response. 4.15. What is the ratio of the Exports(as % of merchandise exports) of Europe(all income levels) in 2002 to that in 2011?
Make the answer very short. 0.66. What is the ratio of the Exports(as % of merchandise exports) of Singapore in 2002 to that in 2011?
Ensure brevity in your answer.  0.39. What is the ratio of the Exports(as % of merchandise exports) of Togo in 2002 to that in 2011?
Offer a very short reply. 0.58. What is the ratio of the Exports(as % of merchandise exports) in Turks and Caicos Islands in 2002 to that in 2011?
Offer a very short reply. 11.23. What is the ratio of the Exports(as % of merchandise exports) in Europe(all income levels) in 2002 to that in 2012?
Offer a terse response. 0.62. What is the ratio of the Exports(as % of merchandise exports) in Singapore in 2002 to that in 2012?
Give a very brief answer. 0.42. What is the ratio of the Exports(as % of merchandise exports) of Togo in 2002 to that in 2012?
Offer a terse response. 0.26. What is the ratio of the Exports(as % of merchandise exports) of Turks and Caicos Islands in 2002 to that in 2012?
Ensure brevity in your answer.  4.3. What is the ratio of the Exports(as % of merchandise exports) of Europe(all income levels) in 2003 to that in 2004?
Offer a terse response. 0.95. What is the ratio of the Exports(as % of merchandise exports) of Singapore in 2003 to that in 2004?
Provide a succinct answer. 0.86. What is the ratio of the Exports(as % of merchandise exports) of Togo in 2003 to that in 2004?
Give a very brief answer. 0.94. What is the ratio of the Exports(as % of merchandise exports) of Turks and Caicos Islands in 2003 to that in 2004?
Provide a short and direct response. 0.05. What is the ratio of the Exports(as % of merchandise exports) in Europe(all income levels) in 2003 to that in 2011?
Your response must be concise. 0.68. What is the ratio of the Exports(as % of merchandise exports) in Singapore in 2003 to that in 2011?
Offer a terse response. 0.43. What is the ratio of the Exports(as % of merchandise exports) of Togo in 2003 to that in 2011?
Your response must be concise. 0.38. What is the ratio of the Exports(as % of merchandise exports) in Turks and Caicos Islands in 2003 to that in 2011?
Ensure brevity in your answer.  0.14. What is the ratio of the Exports(as % of merchandise exports) of Europe(all income levels) in 2003 to that in 2012?
Make the answer very short. 0.65. What is the ratio of the Exports(as % of merchandise exports) of Singapore in 2003 to that in 2012?
Provide a short and direct response. 0.46. What is the ratio of the Exports(as % of merchandise exports) in Togo in 2003 to that in 2012?
Your response must be concise. 0.17. What is the ratio of the Exports(as % of merchandise exports) in Turks and Caicos Islands in 2003 to that in 2012?
Provide a short and direct response. 0.05. What is the ratio of the Exports(as % of merchandise exports) of Europe(all income levels) in 2004 to that in 2011?
Keep it short and to the point. 0.72. What is the ratio of the Exports(as % of merchandise exports) in Singapore in 2004 to that in 2011?
Your answer should be compact. 0.5. What is the ratio of the Exports(as % of merchandise exports) in Togo in 2004 to that in 2011?
Provide a short and direct response. 0.4. What is the ratio of the Exports(as % of merchandise exports) in Turks and Caicos Islands in 2004 to that in 2011?
Your answer should be very brief. 2.71. What is the ratio of the Exports(as % of merchandise exports) of Europe(all income levels) in 2004 to that in 2012?
Your answer should be very brief. 0.68. What is the ratio of the Exports(as % of merchandise exports) of Singapore in 2004 to that in 2012?
Ensure brevity in your answer.  0.53. What is the ratio of the Exports(as % of merchandise exports) of Togo in 2004 to that in 2012?
Your answer should be compact. 0.18. What is the ratio of the Exports(as % of merchandise exports) of Turks and Caicos Islands in 2004 to that in 2012?
Provide a short and direct response. 1.04. What is the ratio of the Exports(as % of merchandise exports) of Europe(all income levels) in 2011 to that in 2012?
Ensure brevity in your answer.  0.95. What is the ratio of the Exports(as % of merchandise exports) in Singapore in 2011 to that in 2012?
Keep it short and to the point. 1.07. What is the ratio of the Exports(as % of merchandise exports) in Togo in 2011 to that in 2012?
Ensure brevity in your answer.  0.46. What is the ratio of the Exports(as % of merchandise exports) of Turks and Caicos Islands in 2011 to that in 2012?
Offer a terse response. 0.38. What is the difference between the highest and the second highest Exports(as % of merchandise exports) in Europe(all income levels)?
Ensure brevity in your answer.  0.67. What is the difference between the highest and the second highest Exports(as % of merchandise exports) of Singapore?
Your answer should be very brief. 1.27. What is the difference between the highest and the second highest Exports(as % of merchandise exports) of Togo?
Your answer should be compact. 1.1. What is the difference between the highest and the second highest Exports(as % of merchandise exports) of Turks and Caicos Islands?
Keep it short and to the point. 0.44. What is the difference between the highest and the lowest Exports(as % of merchandise exports) of Europe(all income levels)?
Make the answer very short. 4.69. What is the difference between the highest and the lowest Exports(as % of merchandise exports) of Singapore?
Your answer should be very brief. 12.44. What is the difference between the highest and the lowest Exports(as % of merchandise exports) in Togo?
Offer a very short reply. 1.67. What is the difference between the highest and the lowest Exports(as % of merchandise exports) in Turks and Caicos Islands?
Give a very brief answer. 0.7. 